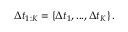Convert formula to latex. <formula><loc_0><loc_0><loc_500><loc_500>\Delta t _ { 1 \colon K } = \left \{ \Delta t _ { 1 } , \dots , \Delta t _ { K } \right \} .</formula> 